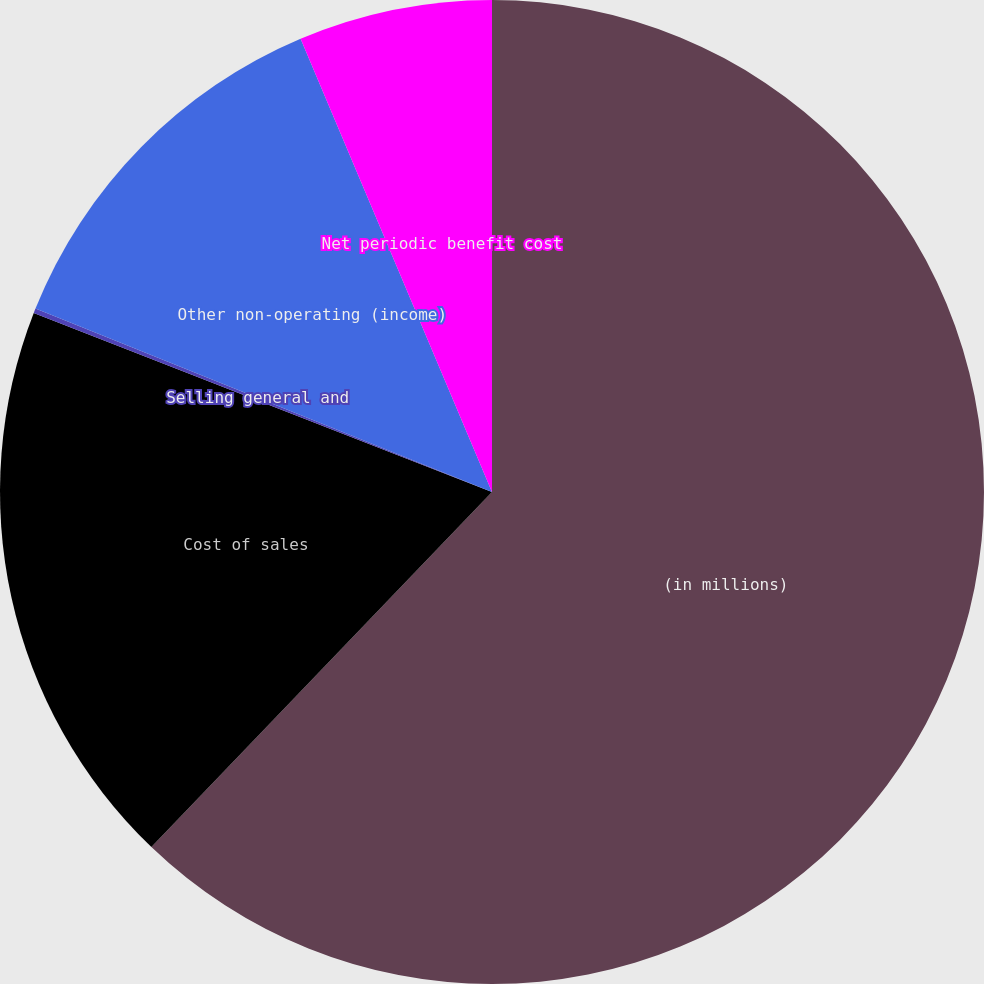Convert chart. <chart><loc_0><loc_0><loc_500><loc_500><pie_chart><fcel>(in millions)<fcel>Cost of sales<fcel>Selling general and<fcel>Other non-operating (income)<fcel>Net periodic benefit cost<nl><fcel>62.17%<fcel>18.76%<fcel>0.15%<fcel>12.56%<fcel>6.36%<nl></chart> 